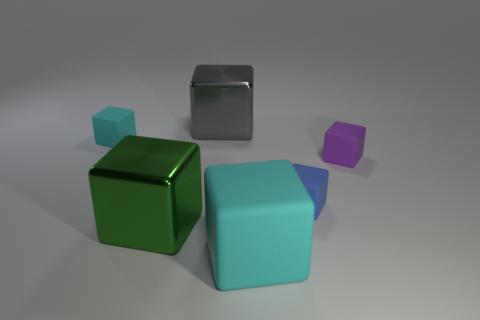There is a cyan matte object that is on the right side of the green thing; is its size the same as the purple object?
Your answer should be compact. No. What material is the tiny thing left of the large cyan object?
Make the answer very short. Rubber. Is the number of gray things greater than the number of big cubes?
Keep it short and to the point. No. What number of objects are tiny rubber things behind the tiny purple rubber thing or big metallic cubes?
Your answer should be compact. 3. There is a matte thing that is left of the big green shiny block; how many small purple rubber objects are right of it?
Make the answer very short. 1. There is a cyan matte cube that is on the right side of the large block behind the cyan block behind the small purple object; what is its size?
Make the answer very short. Large. There is a tiny matte block to the left of the blue block; is its color the same as the big matte object?
Offer a very short reply. Yes. There is a blue rubber thing that is the same shape as the large cyan thing; what is its size?
Make the answer very short. Small. What number of objects are either metallic blocks that are in front of the small cyan rubber thing or things that are behind the green shiny cube?
Keep it short and to the point. 5. Is there any other thing that is the same size as the green metal cube?
Keep it short and to the point. Yes. 